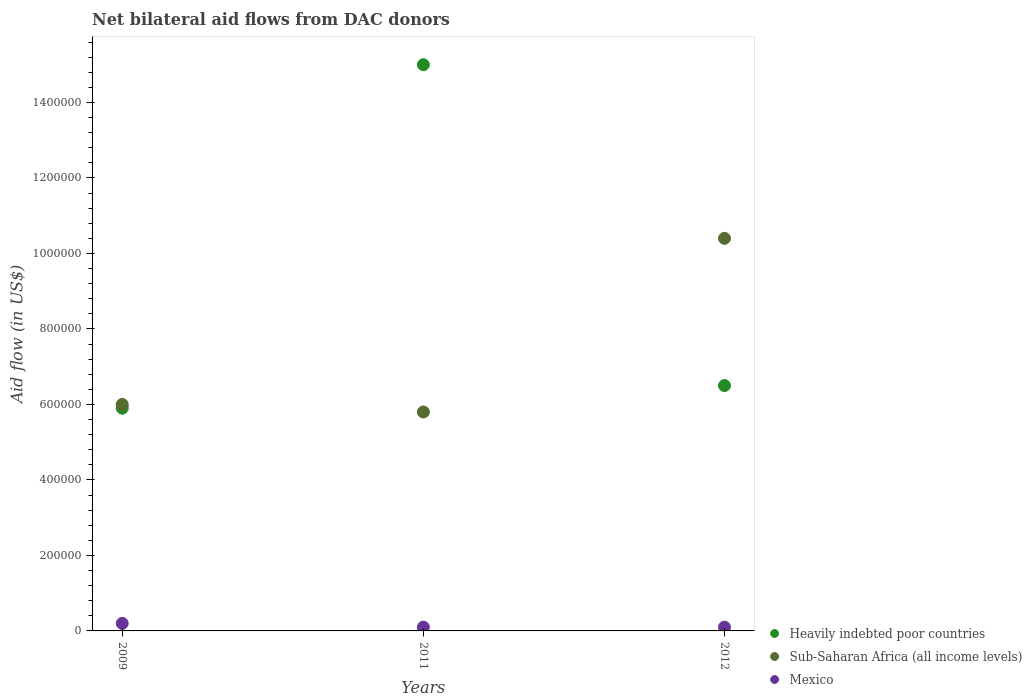How many different coloured dotlines are there?
Your answer should be very brief. 3. Is the number of dotlines equal to the number of legend labels?
Keep it short and to the point. Yes. Across all years, what is the maximum net bilateral aid flow in Heavily indebted poor countries?
Offer a very short reply. 1.50e+06. Across all years, what is the minimum net bilateral aid flow in Mexico?
Ensure brevity in your answer.  10000. What is the total net bilateral aid flow in Sub-Saharan Africa (all income levels) in the graph?
Your response must be concise. 2.22e+06. What is the difference between the net bilateral aid flow in Heavily indebted poor countries in 2009 and that in 2012?
Your answer should be compact. -6.00e+04. What is the difference between the net bilateral aid flow in Sub-Saharan Africa (all income levels) in 2012 and the net bilateral aid flow in Heavily indebted poor countries in 2009?
Offer a terse response. 4.50e+05. What is the average net bilateral aid flow in Sub-Saharan Africa (all income levels) per year?
Give a very brief answer. 7.40e+05. In the year 2012, what is the difference between the net bilateral aid flow in Heavily indebted poor countries and net bilateral aid flow in Mexico?
Your answer should be compact. 6.40e+05. In how many years, is the net bilateral aid flow in Heavily indebted poor countries greater than 920000 US$?
Ensure brevity in your answer.  1. What is the ratio of the net bilateral aid flow in Heavily indebted poor countries in 2011 to that in 2012?
Your response must be concise. 2.31. Is the net bilateral aid flow in Heavily indebted poor countries in 2011 less than that in 2012?
Your response must be concise. No. What is the difference between the highest and the second highest net bilateral aid flow in Heavily indebted poor countries?
Offer a terse response. 8.50e+05. In how many years, is the net bilateral aid flow in Sub-Saharan Africa (all income levels) greater than the average net bilateral aid flow in Sub-Saharan Africa (all income levels) taken over all years?
Offer a very short reply. 1. Does the net bilateral aid flow in Sub-Saharan Africa (all income levels) monotonically increase over the years?
Keep it short and to the point. No. Is the net bilateral aid flow in Sub-Saharan Africa (all income levels) strictly greater than the net bilateral aid flow in Mexico over the years?
Make the answer very short. Yes. How many dotlines are there?
Give a very brief answer. 3. Does the graph contain grids?
Make the answer very short. No. Where does the legend appear in the graph?
Keep it short and to the point. Bottom right. How are the legend labels stacked?
Offer a terse response. Vertical. What is the title of the graph?
Keep it short and to the point. Net bilateral aid flows from DAC donors. What is the label or title of the X-axis?
Your answer should be compact. Years. What is the label or title of the Y-axis?
Provide a succinct answer. Aid flow (in US$). What is the Aid flow (in US$) in Heavily indebted poor countries in 2009?
Your answer should be compact. 5.90e+05. What is the Aid flow (in US$) of Mexico in 2009?
Give a very brief answer. 2.00e+04. What is the Aid flow (in US$) in Heavily indebted poor countries in 2011?
Your response must be concise. 1.50e+06. What is the Aid flow (in US$) in Sub-Saharan Africa (all income levels) in 2011?
Ensure brevity in your answer.  5.80e+05. What is the Aid flow (in US$) in Mexico in 2011?
Provide a short and direct response. 10000. What is the Aid flow (in US$) of Heavily indebted poor countries in 2012?
Keep it short and to the point. 6.50e+05. What is the Aid flow (in US$) of Sub-Saharan Africa (all income levels) in 2012?
Give a very brief answer. 1.04e+06. What is the Aid flow (in US$) in Mexico in 2012?
Make the answer very short. 10000. Across all years, what is the maximum Aid flow (in US$) in Heavily indebted poor countries?
Your answer should be very brief. 1.50e+06. Across all years, what is the maximum Aid flow (in US$) of Sub-Saharan Africa (all income levels)?
Your answer should be very brief. 1.04e+06. Across all years, what is the maximum Aid flow (in US$) in Mexico?
Offer a very short reply. 2.00e+04. Across all years, what is the minimum Aid flow (in US$) of Heavily indebted poor countries?
Offer a very short reply. 5.90e+05. Across all years, what is the minimum Aid flow (in US$) of Sub-Saharan Africa (all income levels)?
Your answer should be very brief. 5.80e+05. Across all years, what is the minimum Aid flow (in US$) in Mexico?
Keep it short and to the point. 10000. What is the total Aid flow (in US$) of Heavily indebted poor countries in the graph?
Provide a succinct answer. 2.74e+06. What is the total Aid flow (in US$) in Sub-Saharan Africa (all income levels) in the graph?
Provide a short and direct response. 2.22e+06. What is the difference between the Aid flow (in US$) of Heavily indebted poor countries in 2009 and that in 2011?
Ensure brevity in your answer.  -9.10e+05. What is the difference between the Aid flow (in US$) in Sub-Saharan Africa (all income levels) in 2009 and that in 2011?
Ensure brevity in your answer.  2.00e+04. What is the difference between the Aid flow (in US$) in Mexico in 2009 and that in 2011?
Give a very brief answer. 10000. What is the difference between the Aid flow (in US$) of Sub-Saharan Africa (all income levels) in 2009 and that in 2012?
Your answer should be compact. -4.40e+05. What is the difference between the Aid flow (in US$) of Mexico in 2009 and that in 2012?
Offer a terse response. 10000. What is the difference between the Aid flow (in US$) in Heavily indebted poor countries in 2011 and that in 2012?
Your answer should be compact. 8.50e+05. What is the difference between the Aid flow (in US$) of Sub-Saharan Africa (all income levels) in 2011 and that in 2012?
Your answer should be compact. -4.60e+05. What is the difference between the Aid flow (in US$) of Mexico in 2011 and that in 2012?
Make the answer very short. 0. What is the difference between the Aid flow (in US$) in Heavily indebted poor countries in 2009 and the Aid flow (in US$) in Sub-Saharan Africa (all income levels) in 2011?
Give a very brief answer. 10000. What is the difference between the Aid flow (in US$) in Heavily indebted poor countries in 2009 and the Aid flow (in US$) in Mexico in 2011?
Your response must be concise. 5.80e+05. What is the difference between the Aid flow (in US$) in Sub-Saharan Africa (all income levels) in 2009 and the Aid flow (in US$) in Mexico in 2011?
Offer a terse response. 5.90e+05. What is the difference between the Aid flow (in US$) in Heavily indebted poor countries in 2009 and the Aid flow (in US$) in Sub-Saharan Africa (all income levels) in 2012?
Offer a terse response. -4.50e+05. What is the difference between the Aid flow (in US$) in Heavily indebted poor countries in 2009 and the Aid flow (in US$) in Mexico in 2012?
Offer a very short reply. 5.80e+05. What is the difference between the Aid flow (in US$) in Sub-Saharan Africa (all income levels) in 2009 and the Aid flow (in US$) in Mexico in 2012?
Offer a terse response. 5.90e+05. What is the difference between the Aid flow (in US$) of Heavily indebted poor countries in 2011 and the Aid flow (in US$) of Mexico in 2012?
Offer a very short reply. 1.49e+06. What is the difference between the Aid flow (in US$) of Sub-Saharan Africa (all income levels) in 2011 and the Aid flow (in US$) of Mexico in 2012?
Ensure brevity in your answer.  5.70e+05. What is the average Aid flow (in US$) of Heavily indebted poor countries per year?
Make the answer very short. 9.13e+05. What is the average Aid flow (in US$) of Sub-Saharan Africa (all income levels) per year?
Provide a succinct answer. 7.40e+05. What is the average Aid flow (in US$) of Mexico per year?
Your response must be concise. 1.33e+04. In the year 2009, what is the difference between the Aid flow (in US$) in Heavily indebted poor countries and Aid flow (in US$) in Sub-Saharan Africa (all income levels)?
Your response must be concise. -10000. In the year 2009, what is the difference between the Aid flow (in US$) of Heavily indebted poor countries and Aid flow (in US$) of Mexico?
Provide a succinct answer. 5.70e+05. In the year 2009, what is the difference between the Aid flow (in US$) of Sub-Saharan Africa (all income levels) and Aid flow (in US$) of Mexico?
Offer a terse response. 5.80e+05. In the year 2011, what is the difference between the Aid flow (in US$) in Heavily indebted poor countries and Aid flow (in US$) in Sub-Saharan Africa (all income levels)?
Make the answer very short. 9.20e+05. In the year 2011, what is the difference between the Aid flow (in US$) of Heavily indebted poor countries and Aid flow (in US$) of Mexico?
Your answer should be very brief. 1.49e+06. In the year 2011, what is the difference between the Aid flow (in US$) of Sub-Saharan Africa (all income levels) and Aid flow (in US$) of Mexico?
Your response must be concise. 5.70e+05. In the year 2012, what is the difference between the Aid flow (in US$) in Heavily indebted poor countries and Aid flow (in US$) in Sub-Saharan Africa (all income levels)?
Provide a succinct answer. -3.90e+05. In the year 2012, what is the difference between the Aid flow (in US$) in Heavily indebted poor countries and Aid flow (in US$) in Mexico?
Offer a very short reply. 6.40e+05. In the year 2012, what is the difference between the Aid flow (in US$) of Sub-Saharan Africa (all income levels) and Aid flow (in US$) of Mexico?
Provide a short and direct response. 1.03e+06. What is the ratio of the Aid flow (in US$) of Heavily indebted poor countries in 2009 to that in 2011?
Give a very brief answer. 0.39. What is the ratio of the Aid flow (in US$) of Sub-Saharan Africa (all income levels) in 2009 to that in 2011?
Give a very brief answer. 1.03. What is the ratio of the Aid flow (in US$) in Heavily indebted poor countries in 2009 to that in 2012?
Your answer should be compact. 0.91. What is the ratio of the Aid flow (in US$) in Sub-Saharan Africa (all income levels) in 2009 to that in 2012?
Give a very brief answer. 0.58. What is the ratio of the Aid flow (in US$) of Mexico in 2009 to that in 2012?
Offer a very short reply. 2. What is the ratio of the Aid flow (in US$) of Heavily indebted poor countries in 2011 to that in 2012?
Your answer should be compact. 2.31. What is the ratio of the Aid flow (in US$) of Sub-Saharan Africa (all income levels) in 2011 to that in 2012?
Keep it short and to the point. 0.56. What is the difference between the highest and the second highest Aid flow (in US$) of Heavily indebted poor countries?
Offer a very short reply. 8.50e+05. What is the difference between the highest and the lowest Aid flow (in US$) in Heavily indebted poor countries?
Provide a succinct answer. 9.10e+05. 